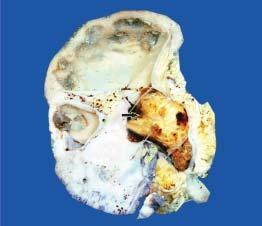s the kidney enlarged and heavy?
Answer the question using a single word or phrase. Yes 